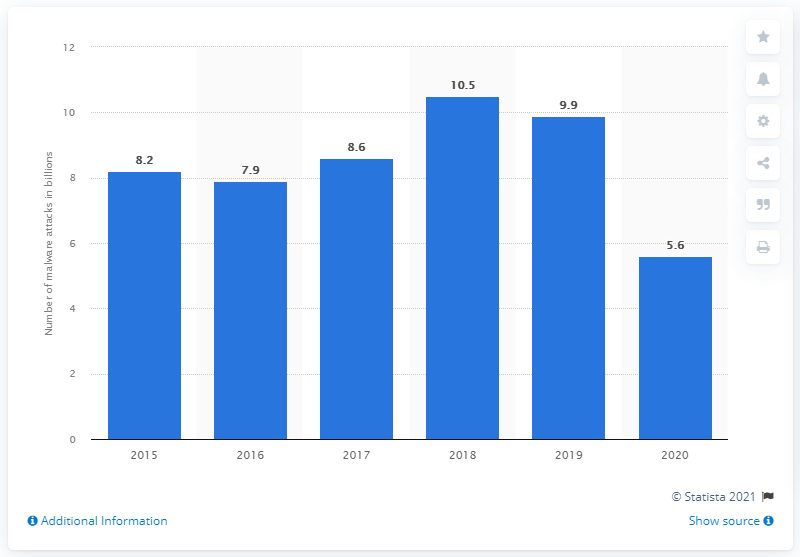List a handful of essential elements in this visual. In the most recent period, 5.6 malware attacks were carried out. During the previous year, approximately 9.9 malware attacks were carried out. 